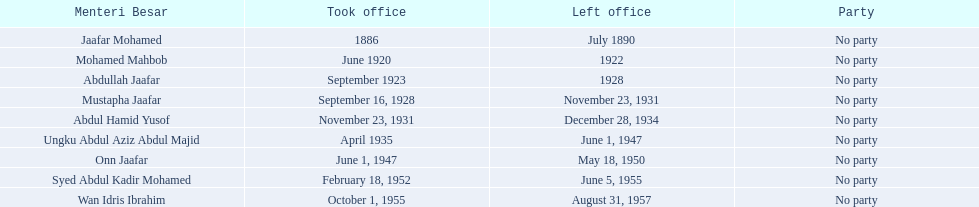Who is mentioned beneath onn jaafar? Syed Abdul Kadir Mohamed. 